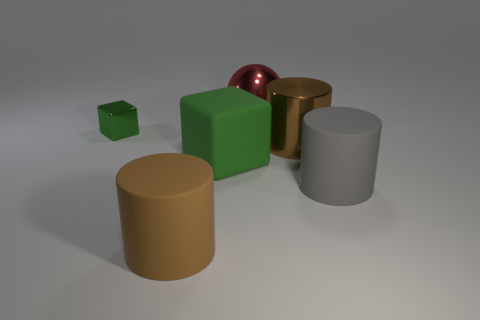Is there anything else that has the same size as the green metallic cube?
Offer a very short reply. No. How many gray rubber things are the same size as the gray matte cylinder?
Keep it short and to the point. 0. What shape is the matte thing that is the same color as the shiny cylinder?
Your response must be concise. Cylinder. Does the cylinder that is left of the big sphere have the same color as the rubber object right of the big shiny sphere?
Keep it short and to the point. No. There is a big shiny sphere; how many large gray rubber objects are on the left side of it?
Ensure brevity in your answer.  0. What is the size of the rubber thing that is the same color as the metal cube?
Ensure brevity in your answer.  Large. Are there any other small matte things of the same shape as the gray rubber object?
Offer a very short reply. No. There is a block that is the same size as the shiny cylinder; what color is it?
Your answer should be very brief. Green. Are there fewer metal cubes in front of the gray rubber object than large blocks that are to the right of the red sphere?
Offer a very short reply. No. Is the size of the brown thing on the right side of the shiny ball the same as the gray thing?
Your answer should be very brief. Yes. 